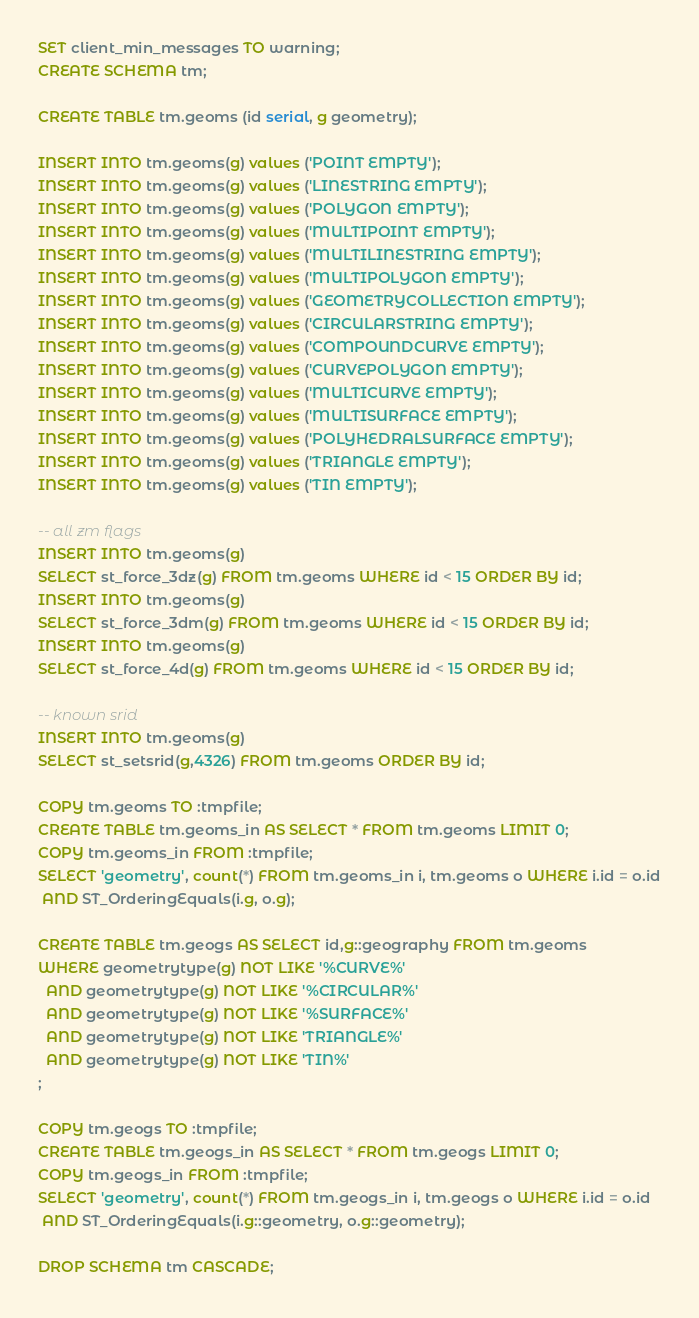Convert code to text. <code><loc_0><loc_0><loc_500><loc_500><_SQL_>SET client_min_messages TO warning;
CREATE SCHEMA tm;

CREATE TABLE tm.geoms (id serial, g geometry);

INSERT INTO tm.geoms(g) values ('POINT EMPTY');
INSERT INTO tm.geoms(g) values ('LINESTRING EMPTY');
INSERT INTO tm.geoms(g) values ('POLYGON EMPTY');
INSERT INTO tm.geoms(g) values ('MULTIPOINT EMPTY');
INSERT INTO tm.geoms(g) values ('MULTILINESTRING EMPTY');
INSERT INTO tm.geoms(g) values ('MULTIPOLYGON EMPTY');
INSERT INTO tm.geoms(g) values ('GEOMETRYCOLLECTION EMPTY');
INSERT INTO tm.geoms(g) values ('CIRCULARSTRING EMPTY');
INSERT INTO tm.geoms(g) values ('COMPOUNDCURVE EMPTY');
INSERT INTO tm.geoms(g) values ('CURVEPOLYGON EMPTY');
INSERT INTO tm.geoms(g) values ('MULTICURVE EMPTY');
INSERT INTO tm.geoms(g) values ('MULTISURFACE EMPTY');
INSERT INTO tm.geoms(g) values ('POLYHEDRALSURFACE EMPTY');
INSERT INTO tm.geoms(g) values ('TRIANGLE EMPTY');
INSERT INTO tm.geoms(g) values ('TIN EMPTY');

-- all zm flags
INSERT INTO tm.geoms(g)
SELECT st_force_3dz(g) FROM tm.geoms WHERE id < 15 ORDER BY id;
INSERT INTO tm.geoms(g)
SELECT st_force_3dm(g) FROM tm.geoms WHERE id < 15 ORDER BY id;
INSERT INTO tm.geoms(g)
SELECT st_force_4d(g) FROM tm.geoms WHERE id < 15 ORDER BY id;

-- known srid
INSERT INTO tm.geoms(g)
SELECT st_setsrid(g,4326) FROM tm.geoms ORDER BY id;

COPY tm.geoms TO :tmpfile;
CREATE TABLE tm.geoms_in AS SELECT * FROM tm.geoms LIMIT 0;
COPY tm.geoms_in FROM :tmpfile;
SELECT 'geometry', count(*) FROM tm.geoms_in i, tm.geoms o WHERE i.id = o.id
 AND ST_OrderingEquals(i.g, o.g);

CREATE TABLE tm.geogs AS SELECT id,g::geography FROM tm.geoms
WHERE geometrytype(g) NOT LIKE '%CURVE%'
  AND geometrytype(g) NOT LIKE '%CIRCULAR%'
  AND geometrytype(g) NOT LIKE '%SURFACE%'
  AND geometrytype(g) NOT LIKE 'TRIANGLE%'
  AND geometrytype(g) NOT LIKE 'TIN%'
;

COPY tm.geogs TO :tmpfile;
CREATE TABLE tm.geogs_in AS SELECT * FROM tm.geogs LIMIT 0;
COPY tm.geogs_in FROM :tmpfile;
SELECT 'geometry', count(*) FROM tm.geogs_in i, tm.geogs o WHERE i.id = o.id
 AND ST_OrderingEquals(i.g::geometry, o.g::geometry);

DROP SCHEMA tm CASCADE;
</code> 